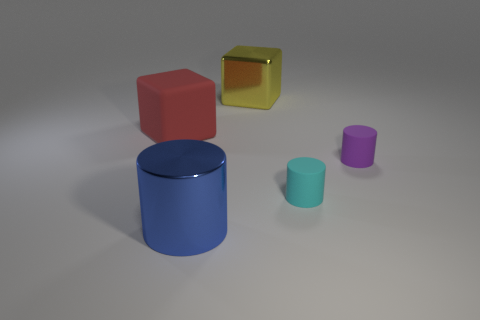There is a rubber thing left of the shiny thing that is to the left of the big metal object that is behind the large cylinder; what is its shape?
Your answer should be very brief. Cube. The large object that is both behind the blue metallic object and to the right of the large red block has what shape?
Give a very brief answer. Cube. What number of things are either tiny cylinders or tiny rubber things left of the tiny purple matte thing?
Ensure brevity in your answer.  2. Does the large red cube have the same material as the yellow object?
Provide a short and direct response. No. How many other things are there of the same shape as the large red rubber object?
Offer a very short reply. 1. How big is the matte thing that is both behind the cyan thing and in front of the red cube?
Give a very brief answer. Small. How many shiny things are purple cylinders or big green spheres?
Your answer should be very brief. 0. There is a tiny thing in front of the small purple cylinder; does it have the same shape as the big thing that is in front of the big red thing?
Offer a terse response. Yes. Is there a cyan cylinder made of the same material as the blue object?
Ensure brevity in your answer.  No. The matte block has what color?
Provide a short and direct response. Red. 